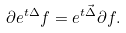Convert formula to latex. <formula><loc_0><loc_0><loc_500><loc_500>\partial e ^ { t \Delta } f = e ^ { t \vec { \Delta } } \partial f .</formula> 